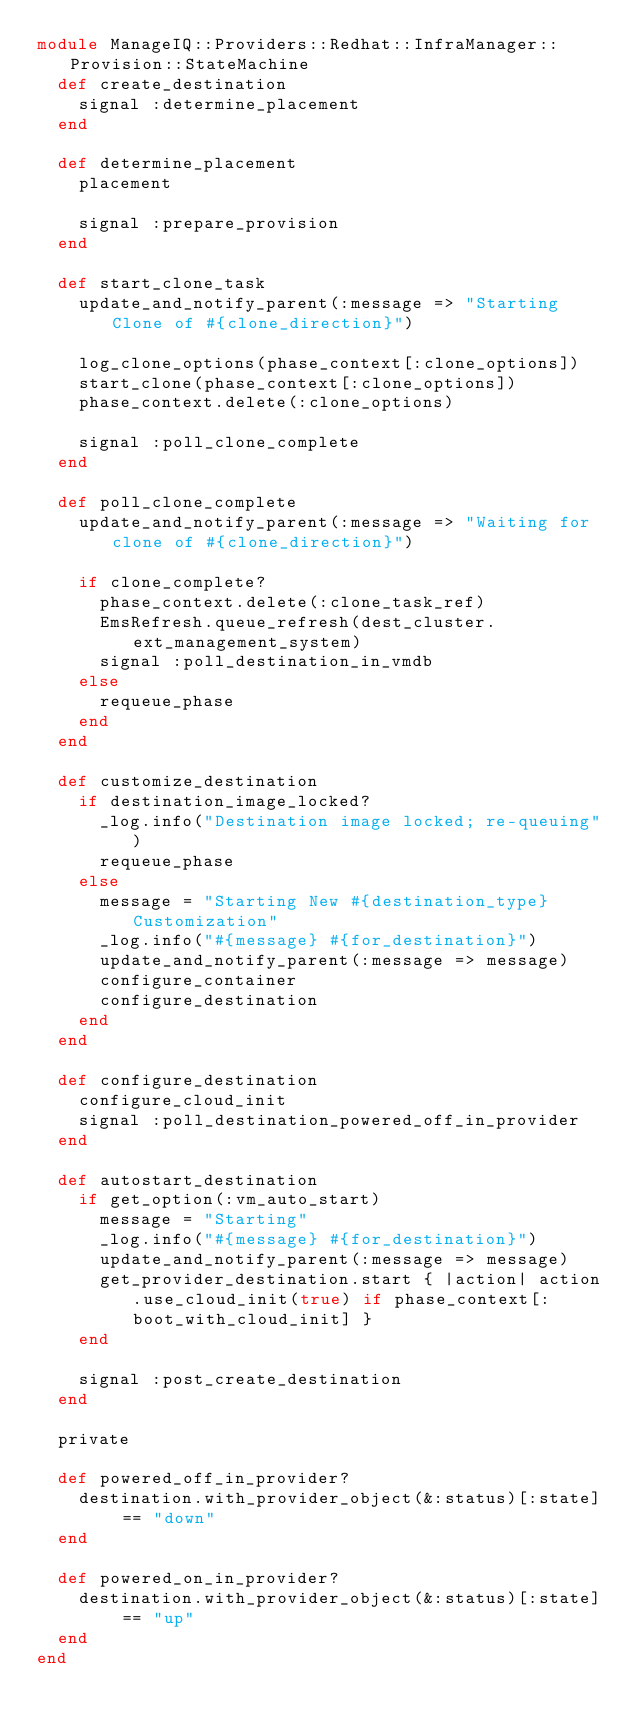Convert code to text. <code><loc_0><loc_0><loc_500><loc_500><_Ruby_>module ManageIQ::Providers::Redhat::InfraManager::Provision::StateMachine
  def create_destination
    signal :determine_placement
  end

  def determine_placement
    placement

    signal :prepare_provision
  end

  def start_clone_task
    update_and_notify_parent(:message => "Starting Clone of #{clone_direction}")

    log_clone_options(phase_context[:clone_options])
    start_clone(phase_context[:clone_options])
    phase_context.delete(:clone_options)

    signal :poll_clone_complete
  end

  def poll_clone_complete
    update_and_notify_parent(:message => "Waiting for clone of #{clone_direction}")

    if clone_complete?
      phase_context.delete(:clone_task_ref)
      EmsRefresh.queue_refresh(dest_cluster.ext_management_system)
      signal :poll_destination_in_vmdb
    else
      requeue_phase
    end
  end

  def customize_destination
    if destination_image_locked?
      _log.info("Destination image locked; re-queuing")
      requeue_phase
    else
      message = "Starting New #{destination_type} Customization"
      _log.info("#{message} #{for_destination}")
      update_and_notify_parent(:message => message)
      configure_container
      configure_destination
    end
  end

  def configure_destination
    configure_cloud_init
    signal :poll_destination_powered_off_in_provider
  end

  def autostart_destination
    if get_option(:vm_auto_start)
      message = "Starting"
      _log.info("#{message} #{for_destination}")
      update_and_notify_parent(:message => message)
      get_provider_destination.start { |action| action.use_cloud_init(true) if phase_context[:boot_with_cloud_init] }
    end

    signal :post_create_destination
  end

  private

  def powered_off_in_provider?
    destination.with_provider_object(&:status)[:state] == "down"
  end

  def powered_on_in_provider?
    destination.with_provider_object(&:status)[:state] == "up"
  end
end
</code> 